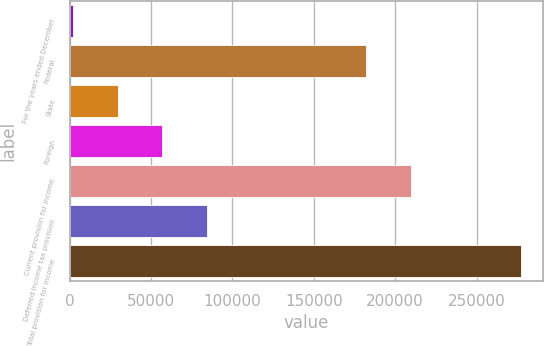Convert chart to OTSL. <chart><loc_0><loc_0><loc_500><loc_500><bar_chart><fcel>For the years ended December<fcel>Federal<fcel>State<fcel>Foreign<fcel>Current provision for income<fcel>Deferred income tax provision<fcel>Total provision for income<nl><fcel>2005<fcel>181947<fcel>29513.5<fcel>57022<fcel>209456<fcel>84530.5<fcel>277090<nl></chart> 